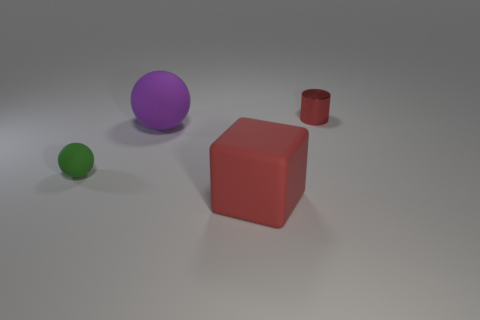Add 2 red metal things. How many objects exist? 6 Subtract all cylinders. How many objects are left? 3 Subtract all big red balls. Subtract all red matte blocks. How many objects are left? 3 Add 4 large cubes. How many large cubes are left? 5 Add 1 tiny green rubber balls. How many tiny green rubber balls exist? 2 Subtract 1 red blocks. How many objects are left? 3 